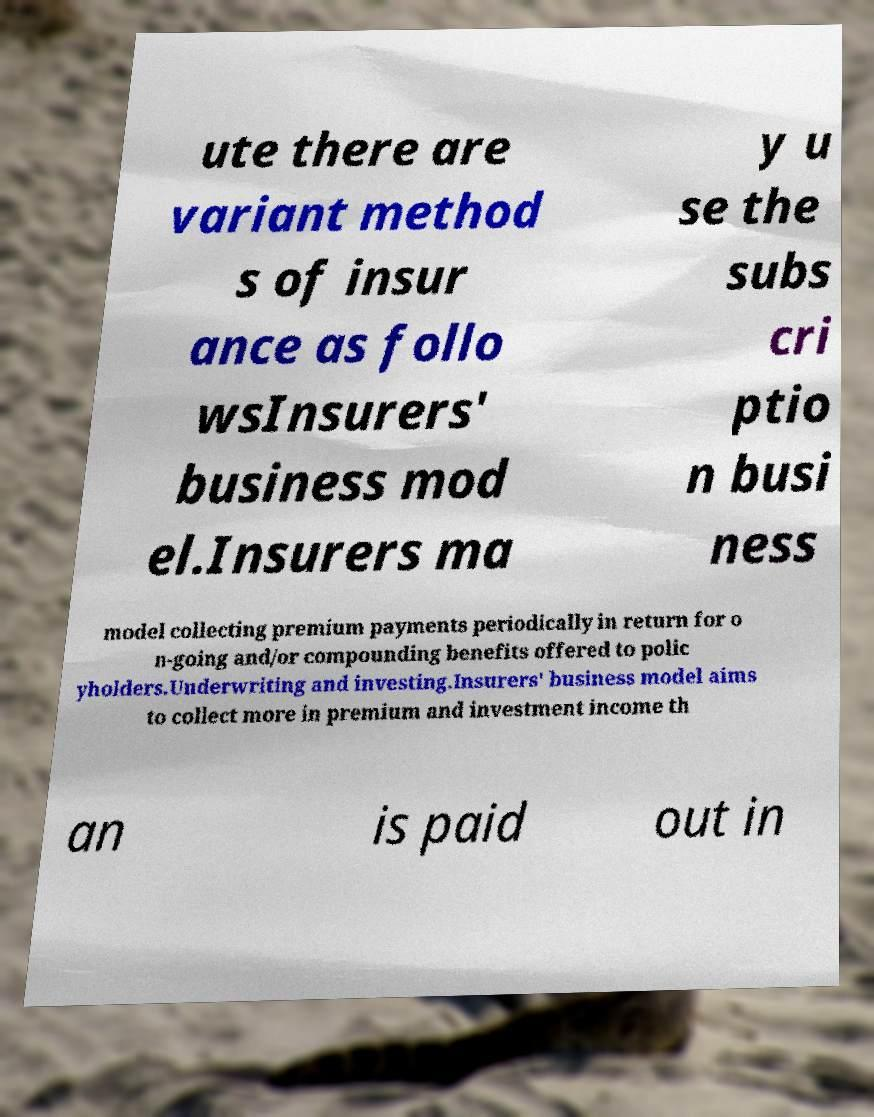Could you extract and type out the text from this image? ute there are variant method s of insur ance as follo wsInsurers' business mod el.Insurers ma y u se the subs cri ptio n busi ness model collecting premium payments periodically in return for o n-going and/or compounding benefits offered to polic yholders.Underwriting and investing.Insurers' business model aims to collect more in premium and investment income th an is paid out in 